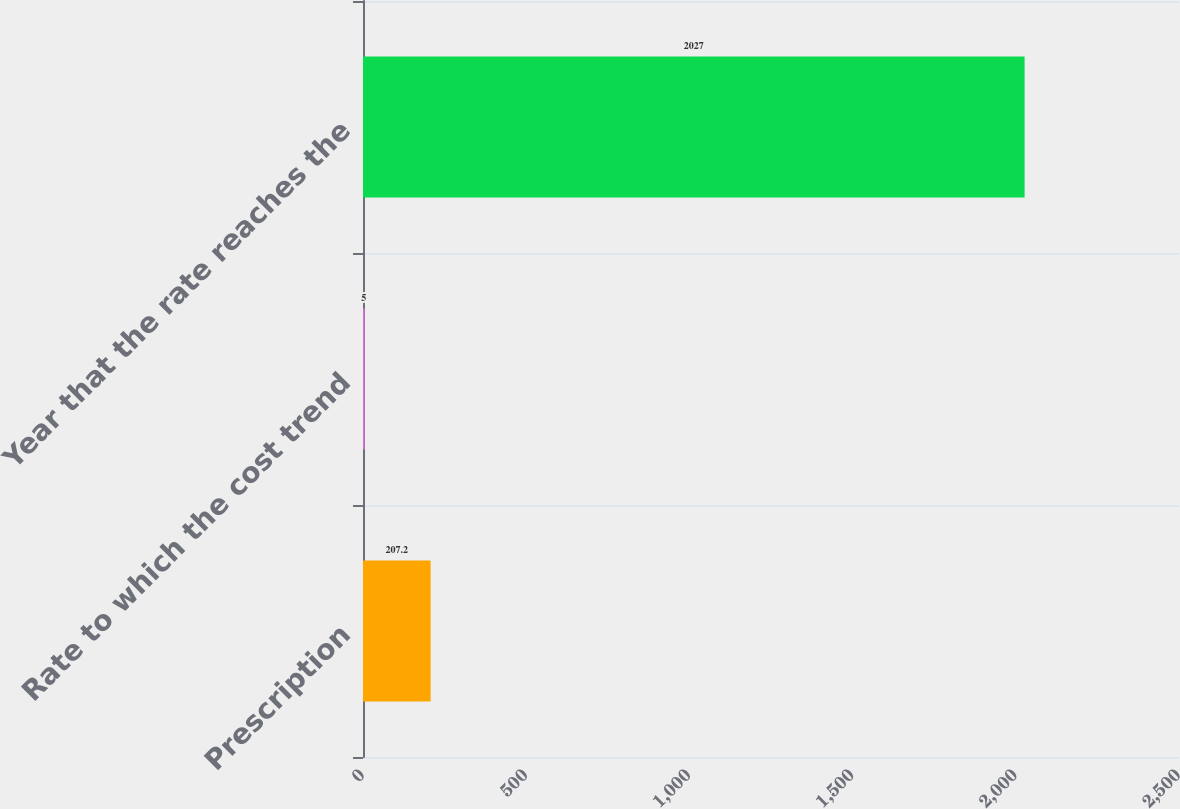Convert chart. <chart><loc_0><loc_0><loc_500><loc_500><bar_chart><fcel>Prescription<fcel>Rate to which the cost trend<fcel>Year that the rate reaches the<nl><fcel>207.2<fcel>5<fcel>2027<nl></chart> 